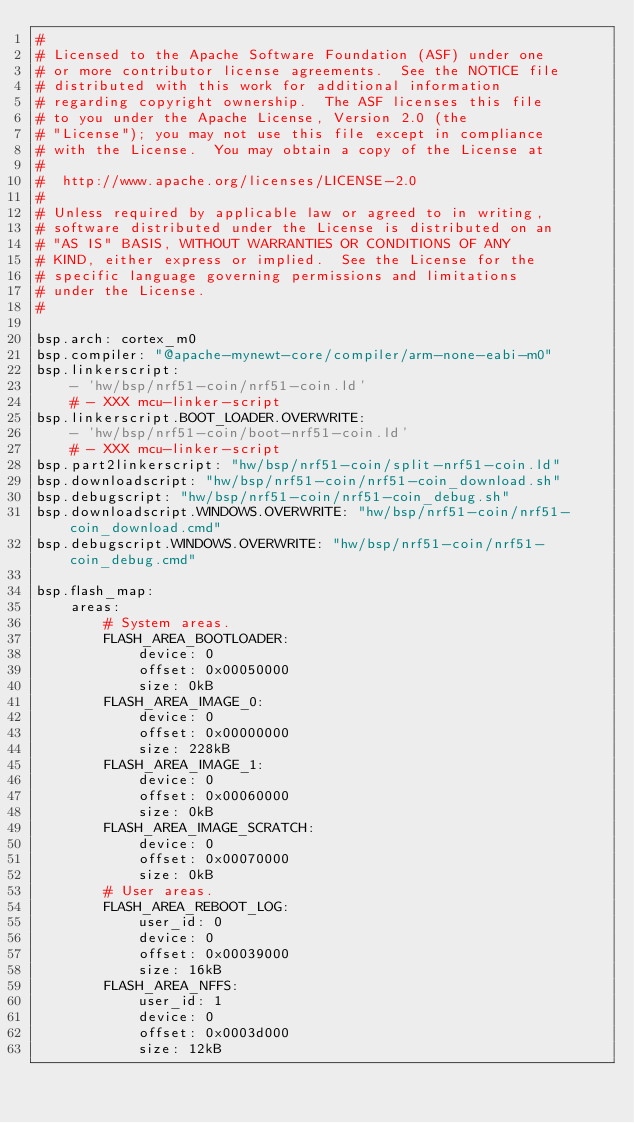<code> <loc_0><loc_0><loc_500><loc_500><_YAML_>#
# Licensed to the Apache Software Foundation (ASF) under one
# or more contributor license agreements.  See the NOTICE file
# distributed with this work for additional information
# regarding copyright ownership.  The ASF licenses this file
# to you under the Apache License, Version 2.0 (the
# "License"); you may not use this file except in compliance
# with the License.  You may obtain a copy of the License at
#
#  http://www.apache.org/licenses/LICENSE-2.0
#
# Unless required by applicable law or agreed to in writing,
# software distributed under the License is distributed on an
# "AS IS" BASIS, WITHOUT WARRANTIES OR CONDITIONS OF ANY
# KIND, either express or implied.  See the License for the
# specific language governing permissions and limitations
# under the License.
#

bsp.arch: cortex_m0
bsp.compiler: "@apache-mynewt-core/compiler/arm-none-eabi-m0"
bsp.linkerscript:
    - 'hw/bsp/nrf51-coin/nrf51-coin.ld'
    # - XXX mcu-linker-script
bsp.linkerscript.BOOT_LOADER.OVERWRITE:
    - 'hw/bsp/nrf51-coin/boot-nrf51-coin.ld'
    # - XXX mcu-linker-script
bsp.part2linkerscript: "hw/bsp/nrf51-coin/split-nrf51-coin.ld"
bsp.downloadscript: "hw/bsp/nrf51-coin/nrf51-coin_download.sh"
bsp.debugscript: "hw/bsp/nrf51-coin/nrf51-coin_debug.sh"
bsp.downloadscript.WINDOWS.OVERWRITE: "hw/bsp/nrf51-coin/nrf51-coin_download.cmd"
bsp.debugscript.WINDOWS.OVERWRITE: "hw/bsp/nrf51-coin/nrf51-coin_debug.cmd"

bsp.flash_map:
    areas:
        # System areas.
        FLASH_AREA_BOOTLOADER:
            device: 0
            offset: 0x00050000
            size: 0kB
        FLASH_AREA_IMAGE_0:
            device: 0
            offset: 0x00000000
            size: 228kB
        FLASH_AREA_IMAGE_1:
            device: 0
            offset: 0x00060000
            size: 0kB
        FLASH_AREA_IMAGE_SCRATCH:
            device: 0
            offset: 0x00070000
            size: 0kB
        # User areas.
        FLASH_AREA_REBOOT_LOG:
            user_id: 0
            device: 0
            offset: 0x00039000
            size: 16kB
        FLASH_AREA_NFFS:
            user_id: 1
            device: 0
            offset: 0x0003d000
            size: 12kB
</code> 